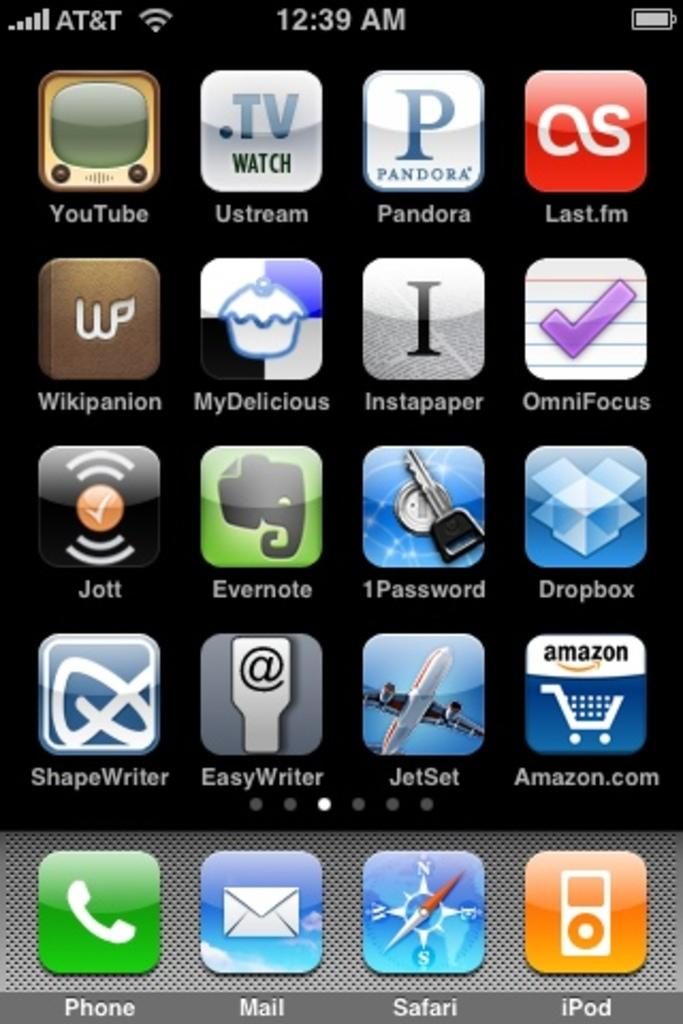<image>
Summarize the visual content of the image. A cellphone screen shows connection through AT&T and various application icons. 